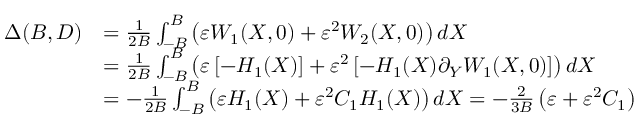<formula> <loc_0><loc_0><loc_500><loc_500>\begin{array} { r l } { \Delta ( B , D ) } & { = \frac { 1 } { 2 B } \int _ { - B } ^ { B } \left ( \varepsilon W _ { 1 } ( X , 0 ) + \varepsilon ^ { 2 } W _ { 2 } ( X , 0 ) \right ) d X } \\ & { = \frac { 1 } { 2 B } \int _ { - B } ^ { B } \left ( \varepsilon \left [ - H _ { 1 } ( X ) \right ] + \varepsilon ^ { 2 } \left [ - H _ { 1 } ( X ) \partial _ { Y } W _ { 1 } ( X , 0 ) \right ] \right ) d X } \\ & { = - \frac { 1 } { 2 B } \int _ { - B } ^ { B } \left ( \varepsilon H _ { 1 } ( X ) + \varepsilon ^ { 2 } C _ { 1 } H _ { 1 } ( X ) \right ) d X = - \frac { 2 } { 3 B } \left ( \varepsilon + \varepsilon ^ { 2 } C _ { 1 } \right ) } \end{array}</formula> 